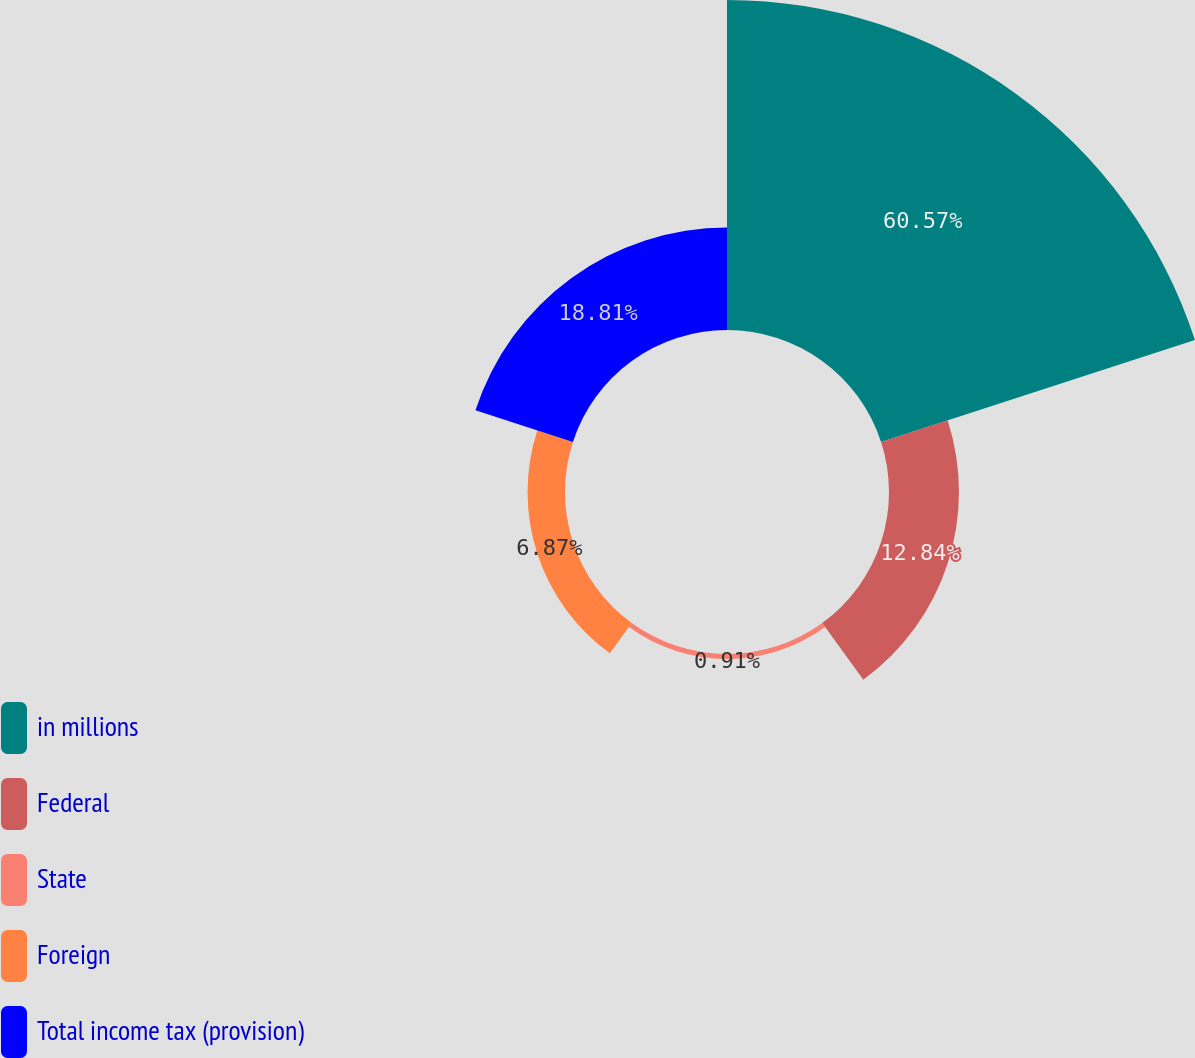<chart> <loc_0><loc_0><loc_500><loc_500><pie_chart><fcel>in millions<fcel>Federal<fcel>State<fcel>Foreign<fcel>Total income tax (provision)<nl><fcel>60.57%<fcel>12.84%<fcel>0.91%<fcel>6.87%<fcel>18.81%<nl></chart> 